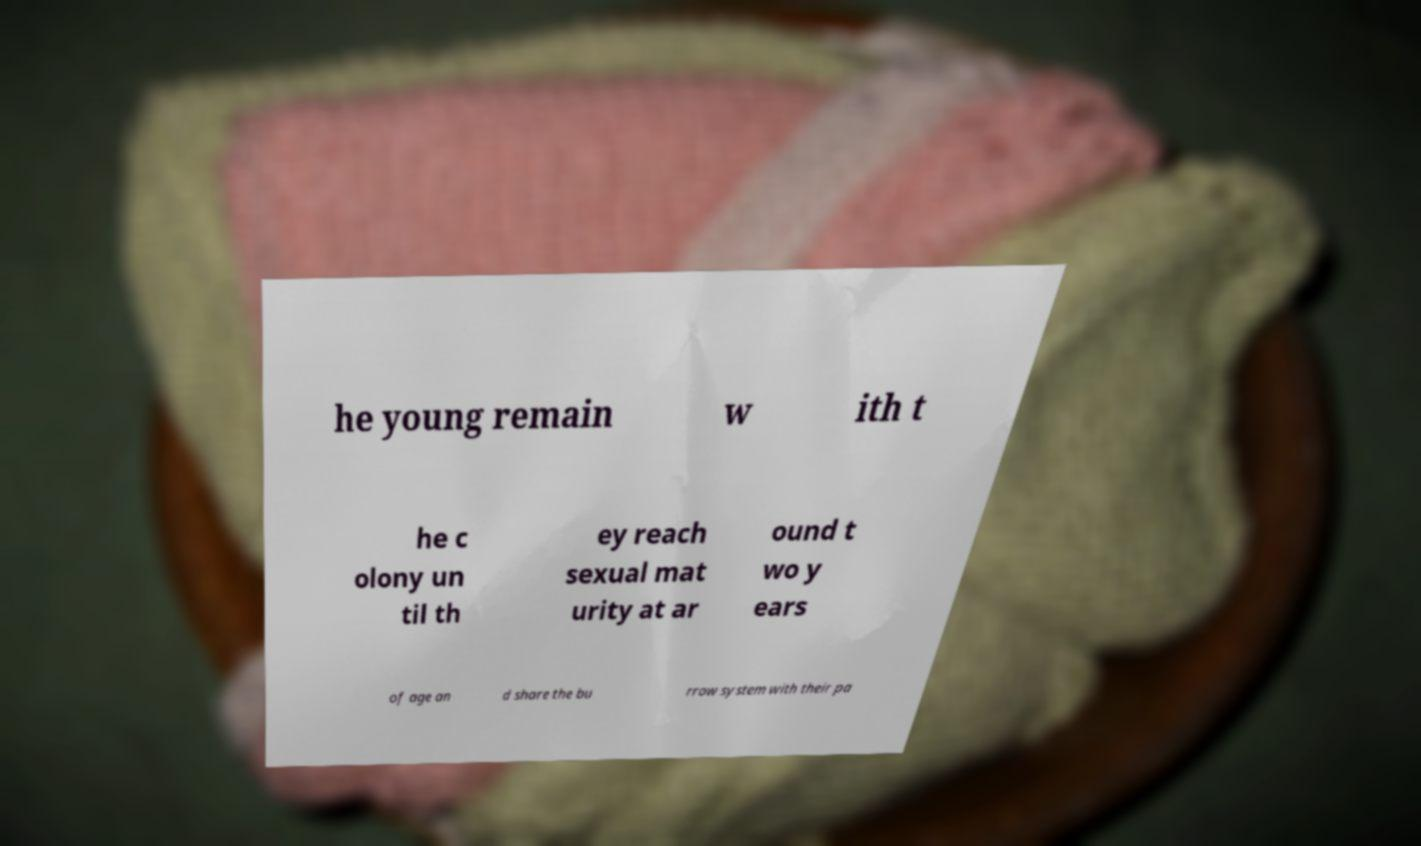Could you assist in decoding the text presented in this image and type it out clearly? he young remain w ith t he c olony un til th ey reach sexual mat urity at ar ound t wo y ears of age an d share the bu rrow system with their pa 